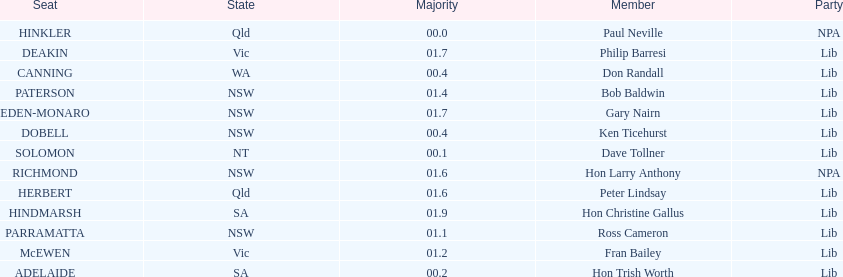What is the total of seats? 13. 